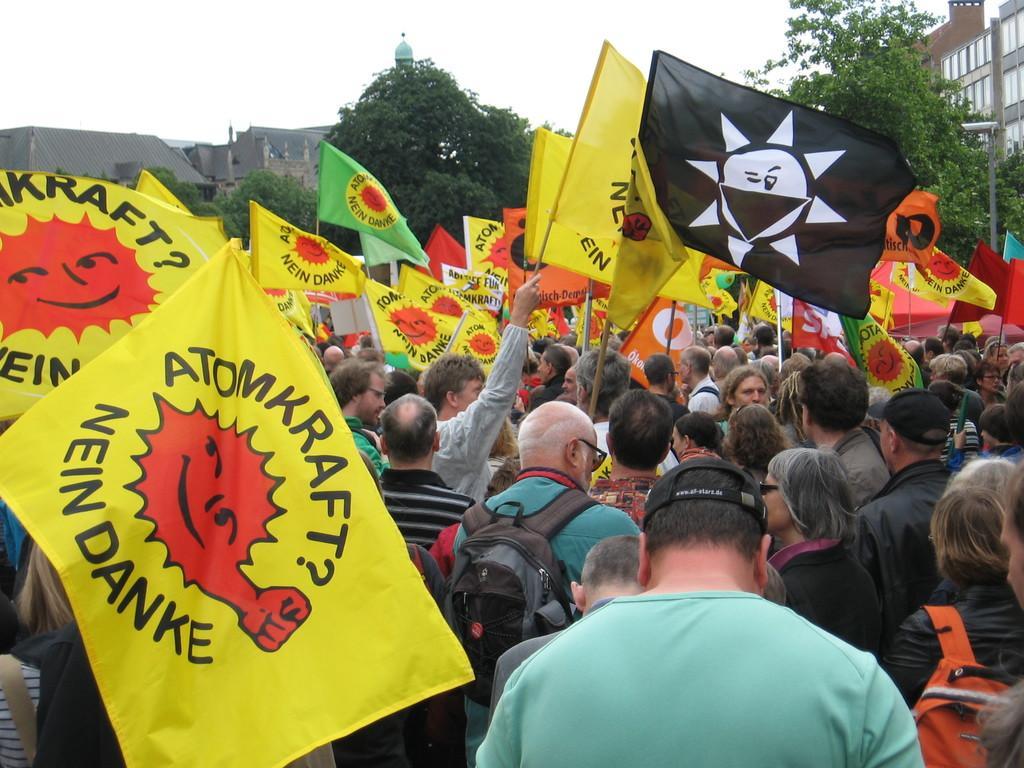Please provide a concise description of this image. In the center of the image a group of people are standing and some of them are holding flags and bags are carrying. In the background of the image we can see a buildings, trees and electric pole are present. At the top of the image sky is there. 